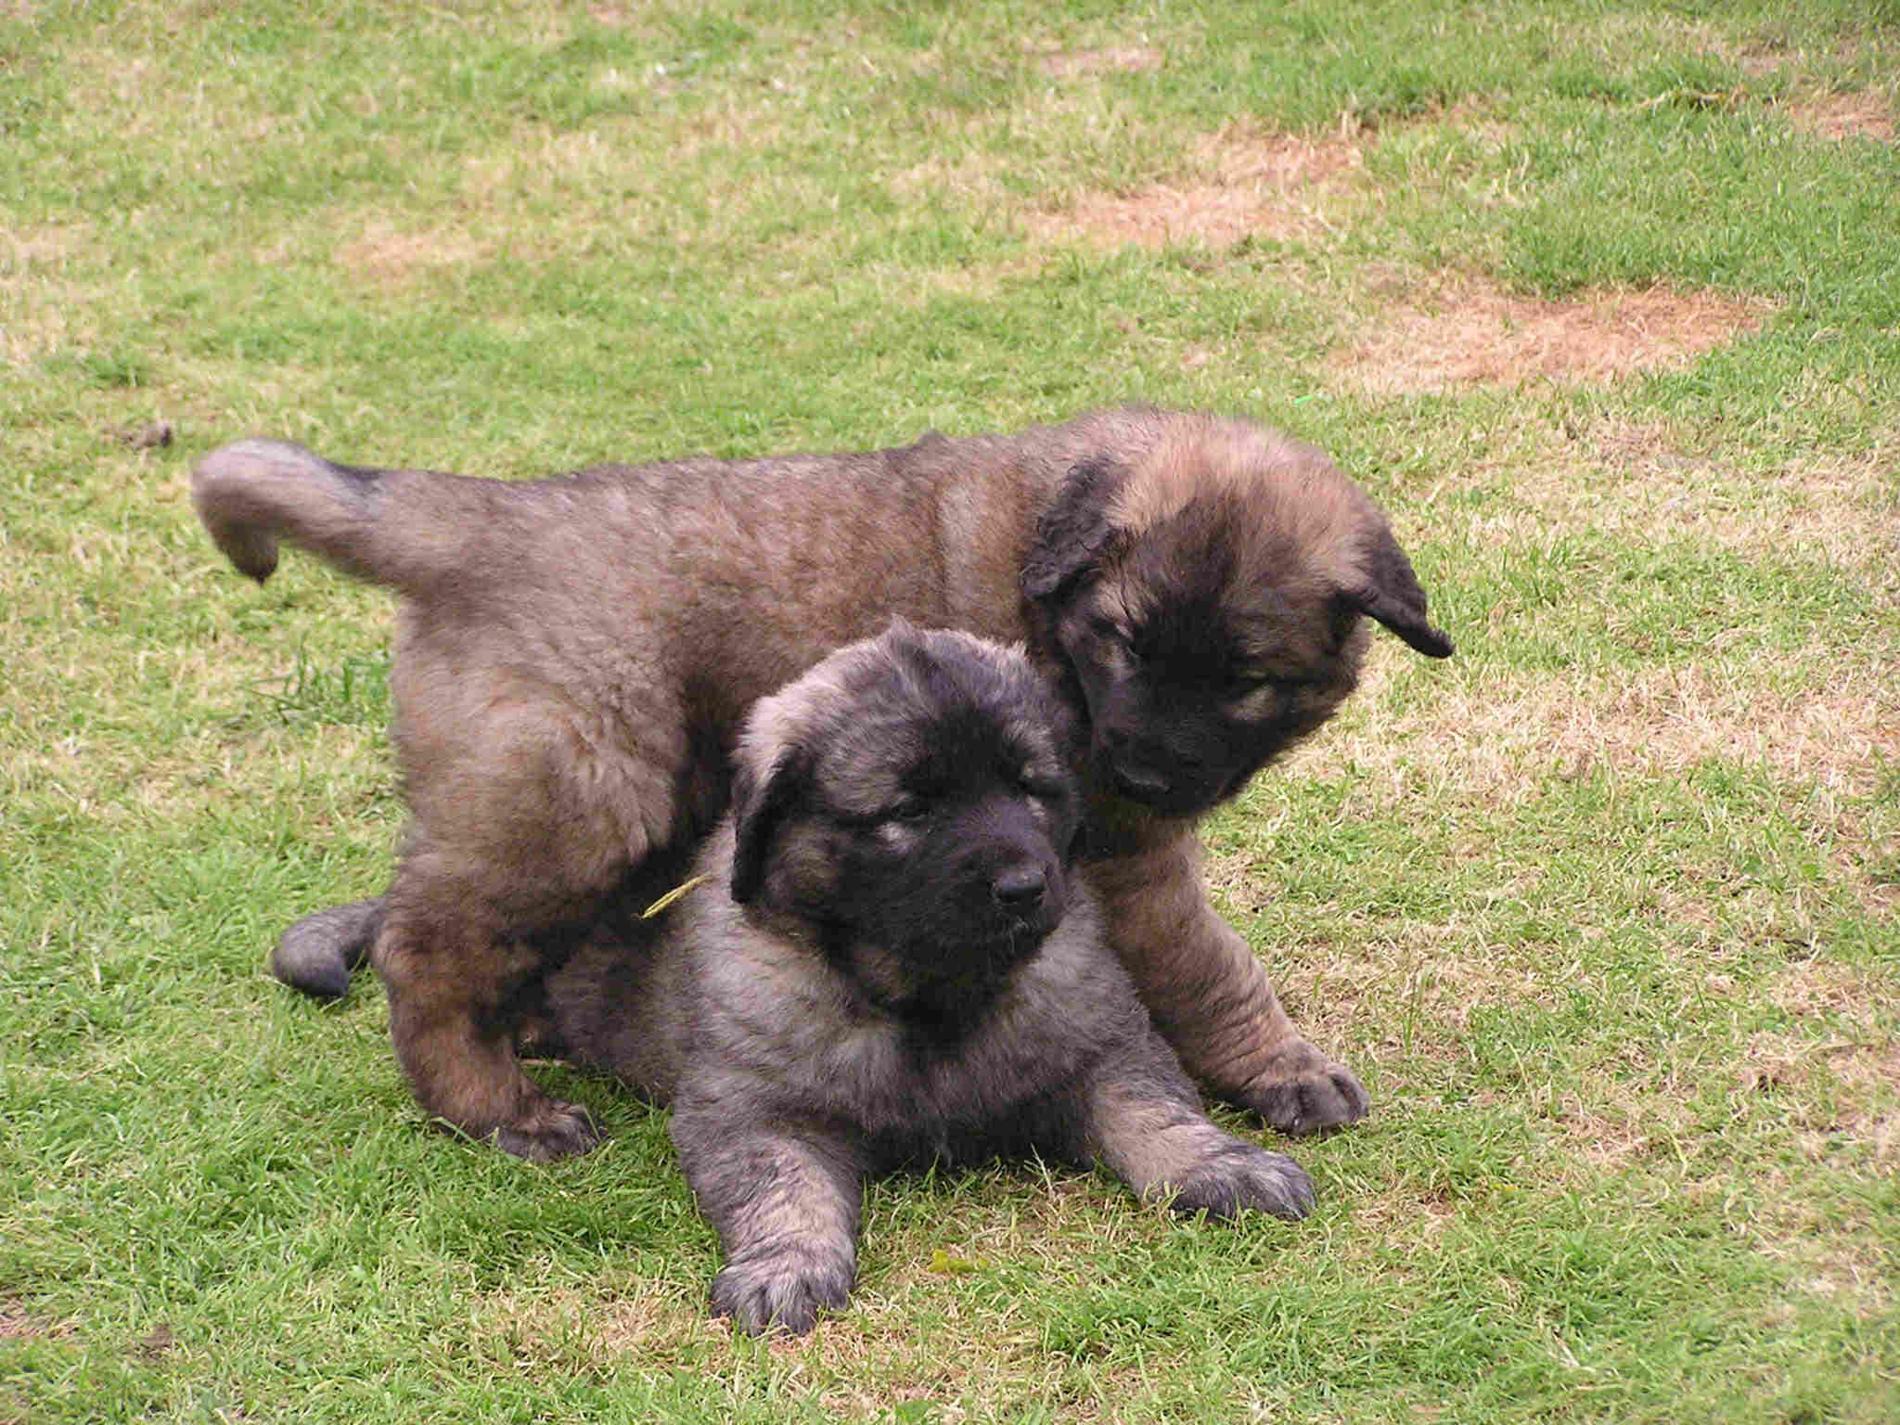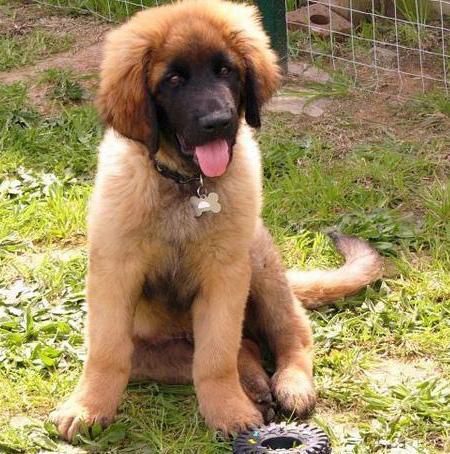The first image is the image on the left, the second image is the image on the right. Evaluate the accuracy of this statement regarding the images: "There are two dogs in the image on the right.". Is it true? Answer yes or no. No. The first image is the image on the left, the second image is the image on the right. Given the left and right images, does the statement "One dog is positioned on the back of another dog." hold true? Answer yes or no. Yes. 